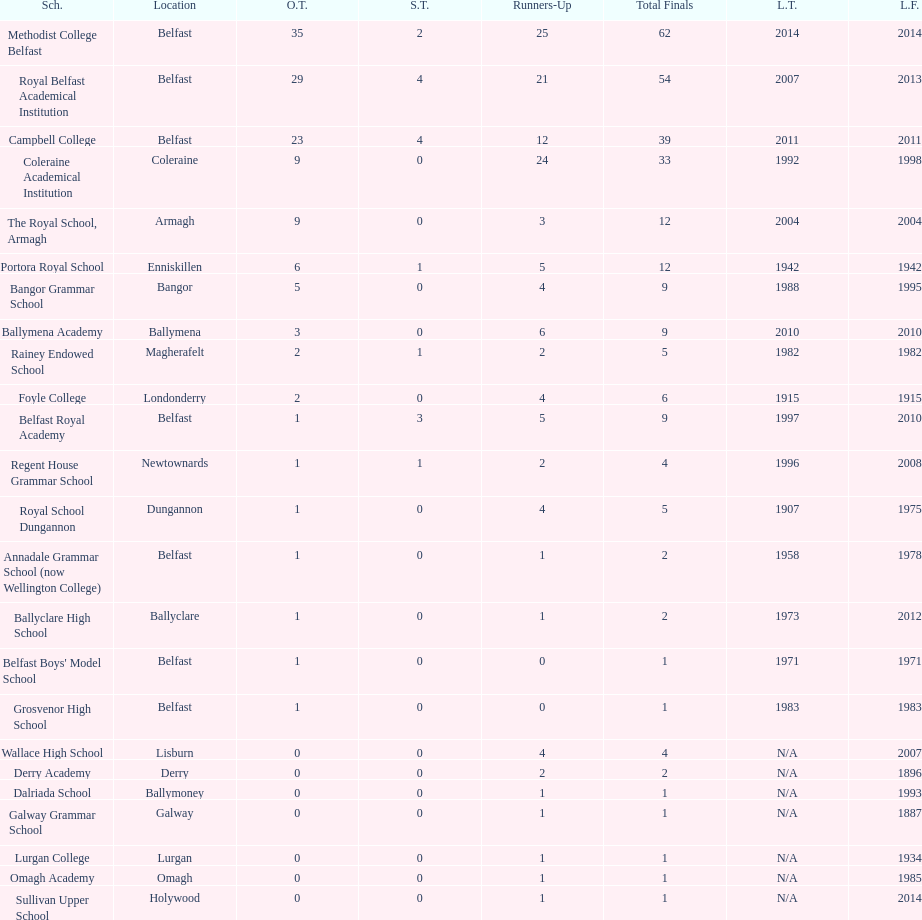What is the difference in runners-up from coleraine academical institution and royal school dungannon? 20. 